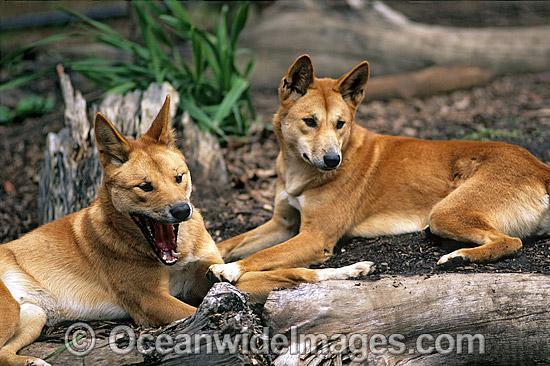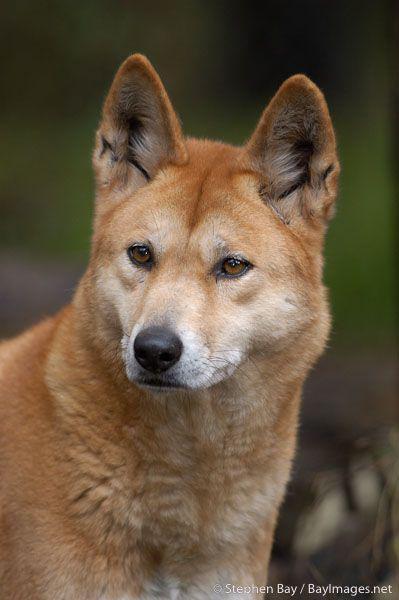The first image is the image on the left, the second image is the image on the right. Analyze the images presented: Is the assertion "There are three dogs" valid? Answer yes or no. Yes. 